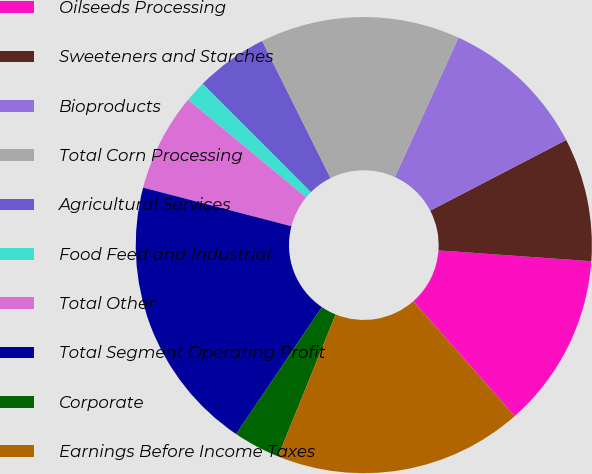Convert chart to OTSL. <chart><loc_0><loc_0><loc_500><loc_500><pie_chart><fcel>Oilseeds Processing<fcel>Sweeteners and Starches<fcel>Bioproducts<fcel>Total Corn Processing<fcel>Agricultural Services<fcel>Food Feed and Industrial<fcel>Total Other<fcel>Total Segment Operating Profit<fcel>Corporate<fcel>Earnings Before Income Taxes<nl><fcel>12.37%<fcel>8.75%<fcel>10.56%<fcel>14.18%<fcel>5.13%<fcel>1.51%<fcel>6.94%<fcel>19.6%<fcel>3.32%<fcel>17.64%<nl></chart> 